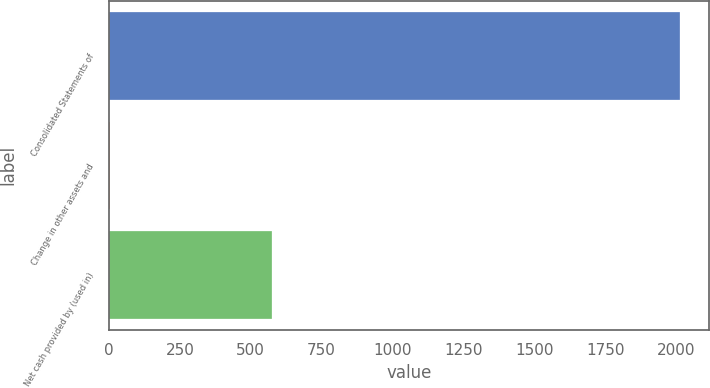<chart> <loc_0><loc_0><loc_500><loc_500><bar_chart><fcel>Consolidated Statements of<fcel>Change in other assets and<fcel>Net cash provided by (used in)<nl><fcel>2015<fcel>2.7<fcel>573.2<nl></chart> 